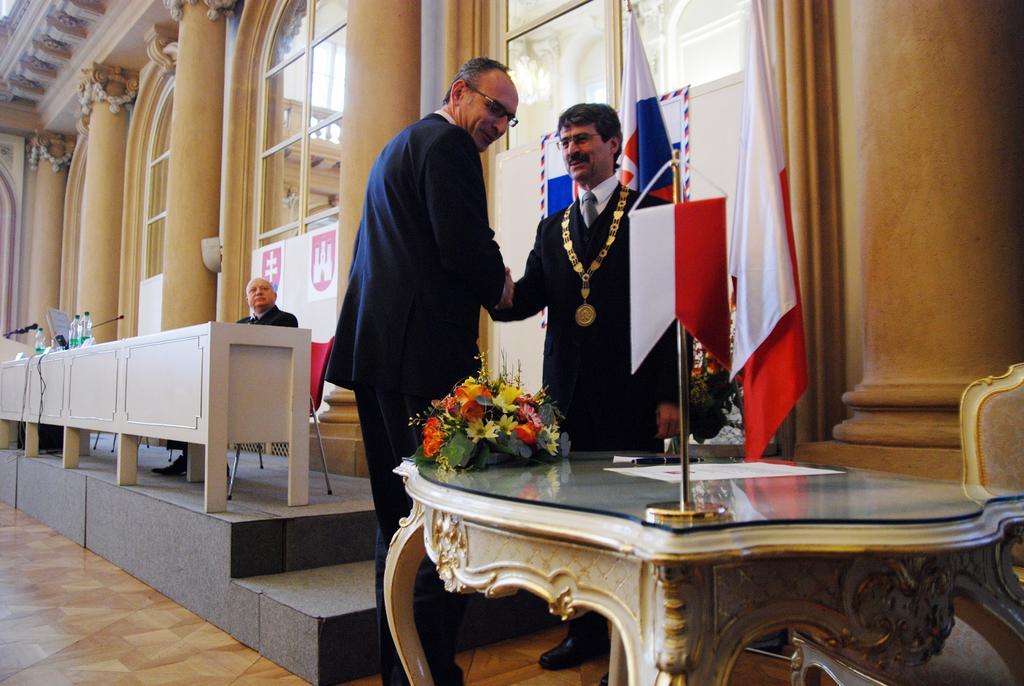Could you give a brief overview of what you see in this image? In this image On the right there is a table on that there is a flag, flower vase and paper. In the middle there are two people. On the left there is a man he is sitting on the chair and there is table,bottle and mic. In the back ground there are flags, window, pillar, staircase and wall. 